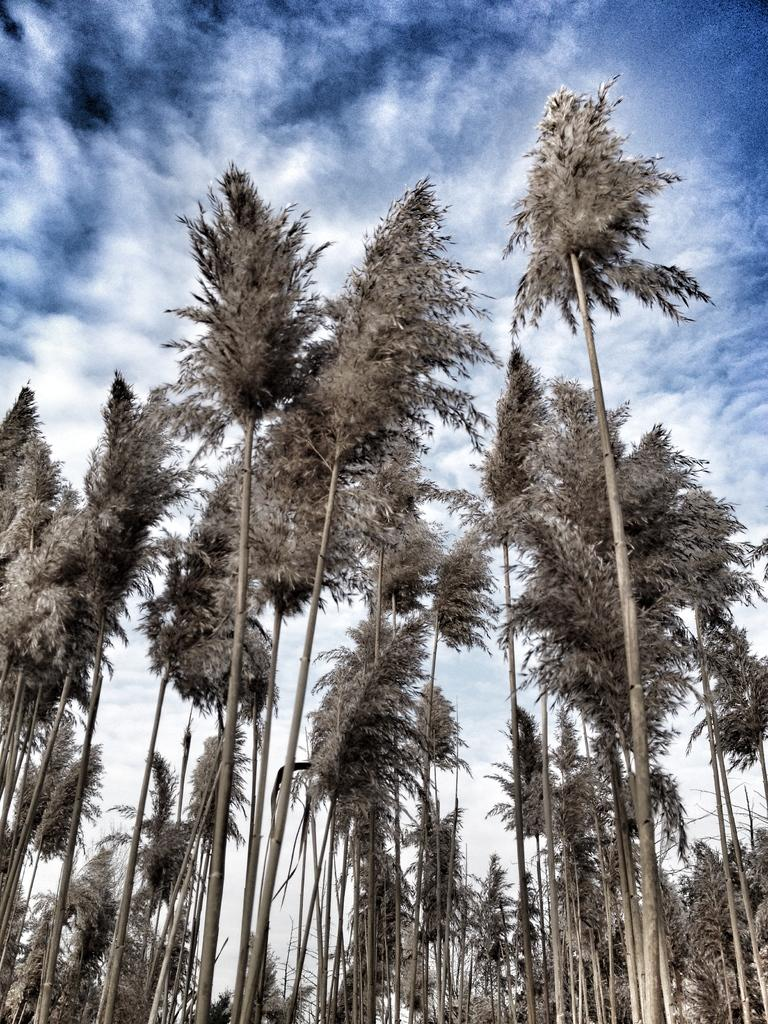What type of vegetation can be seen in the image? There are tall trees in the image. What part of the natural environment is visible in the image? The sky is visible in the image. What can be observed in the sky? Clouds are present in the sky. What type of bottle can be seen in the image? There is no bottle present in the image. What is happening in the back of the image? The term "back" is not applicable to the image, as it is a two-dimensional representation. 